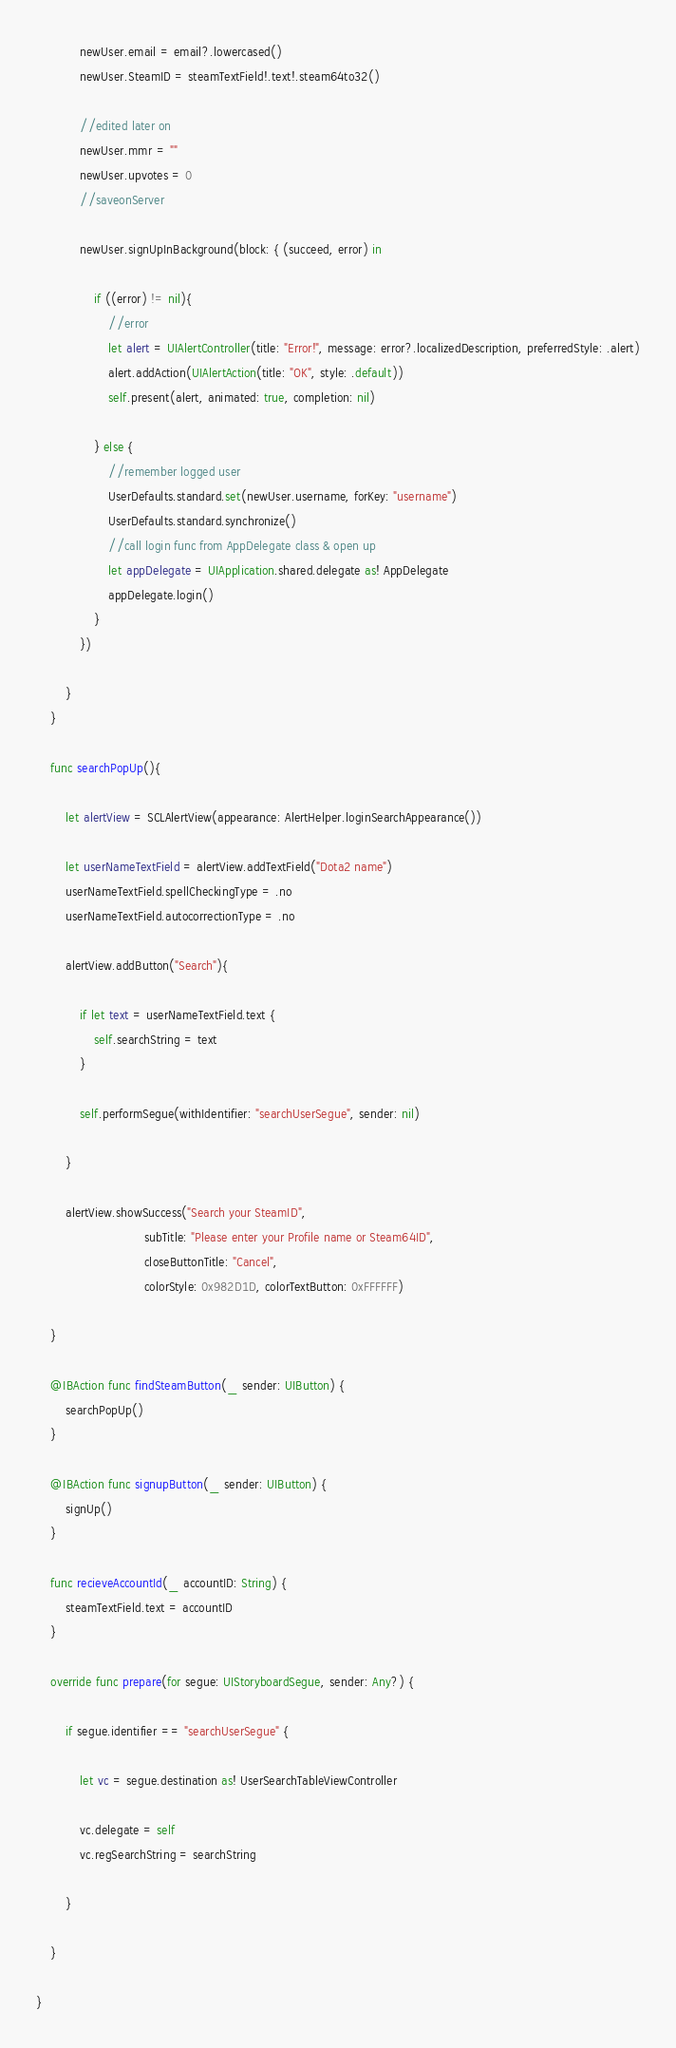<code> <loc_0><loc_0><loc_500><loc_500><_Swift_>            newUser.email = email?.lowercased()
            newUser.SteamID = steamTextField!.text!.steam64to32()
            
            //edited later on
            newUser.mmr = ""
            newUser.upvotes = 0
            //saveonServer
            
            newUser.signUpInBackground(block: { (succeed, error) in
            
                if ((error) != nil){
                    //error
                    let alert = UIAlertController(title: "Error!", message: error?.localizedDescription, preferredStyle: .alert)
                    alert.addAction(UIAlertAction(title: "OK", style: .default))
                    self.present(alert, animated: true, completion: nil)
                    
                } else {
                    //remember logged user
                    UserDefaults.standard.set(newUser.username, forKey: "username")
                    UserDefaults.standard.synchronize()
                    //call login func from AppDelegate class & open up
                    let appDelegate = UIApplication.shared.delegate as! AppDelegate
                    appDelegate.login()
                }
            })
            
        }
    }
    
    func searchPopUp(){
        
        let alertView = SCLAlertView(appearance: AlertHelper.loginSearchAppearance())
        
        let userNameTextField = alertView.addTextField("Dota2 name")
        userNameTextField.spellCheckingType = .no
        userNameTextField.autocorrectionType = .no
        
        alertView.addButton("Search"){
            
            if let text = userNameTextField.text {
                self.searchString = text
            }
            
            self.performSegue(withIdentifier: "searchUserSegue", sender: nil)
            
        }
        
        alertView.showSuccess("Search your SteamID",
                              subTitle: "Please enter your Profile name or Steam64ID",
                              closeButtonTitle: "Cancel",
                              colorStyle: 0x982D1D, colorTextButton: 0xFFFFFF)
        
    }
    
    @IBAction func findSteamButton(_ sender: UIButton) {
        searchPopUp()
    }
    
    @IBAction func signupButton(_ sender: UIButton) {
        signUp()
    }
    
    func recieveAccountId(_ accountID: String) {
        steamTextField.text = accountID
    }
    
    override func prepare(for segue: UIStoryboardSegue, sender: Any?) {
        
        if segue.identifier == "searchUserSegue" {
            
            let vc = segue.destination as! UserSearchTableViewController
            
            vc.delegate = self
            vc.regSearchString = searchString
            
        }
     
    }
    
}
</code> 